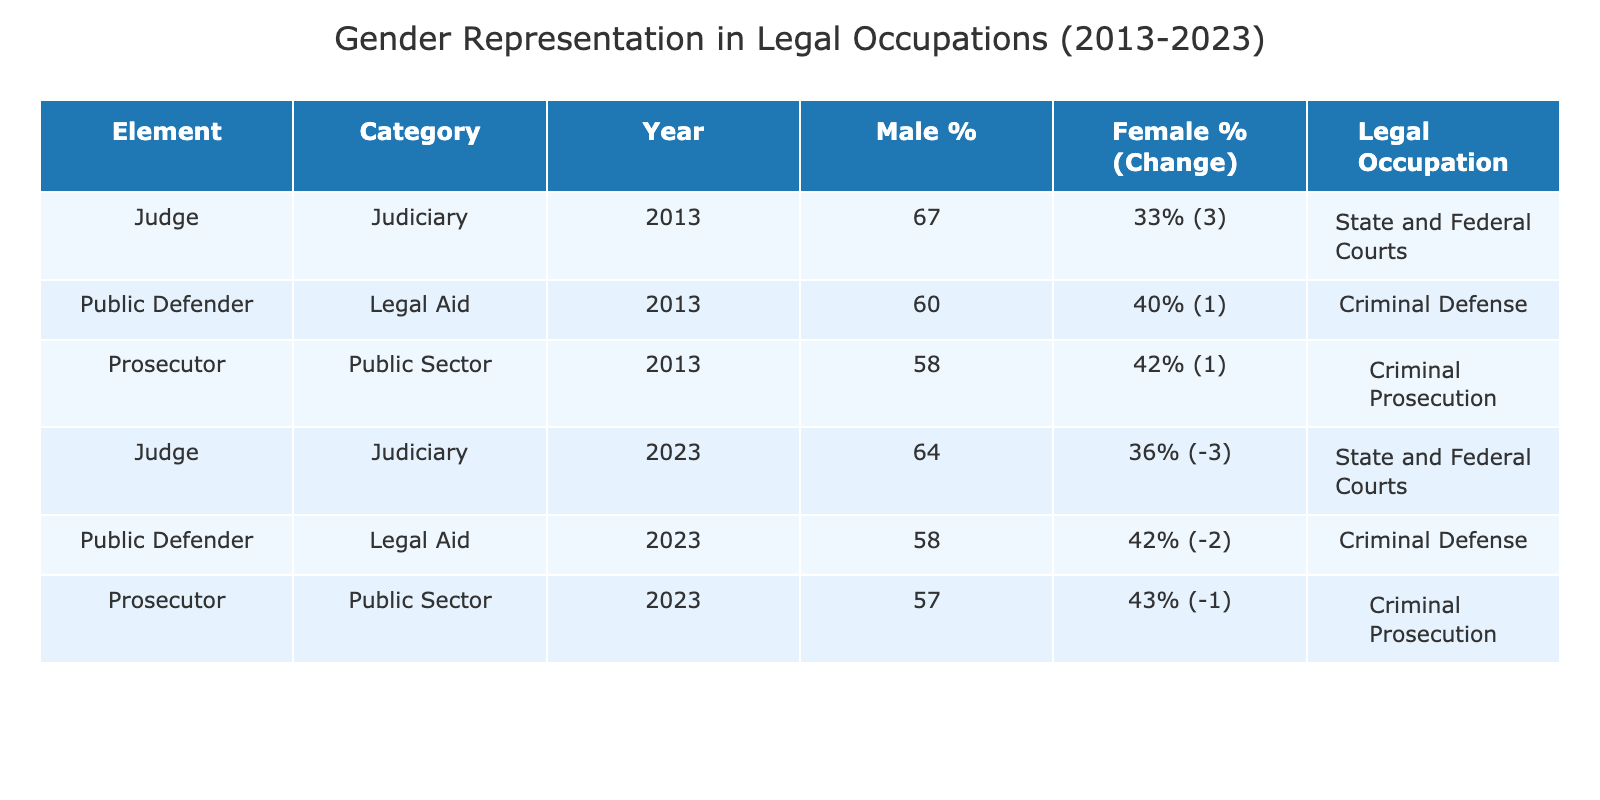What was the female percentage for judges in 2023? The table indicates that for judges in 2023, the female percentage is listed under the female percentage column. From the data, the female percentage is 36%.
Answer: 36% What is the representation change for public defenders from 2013 to 2023? To find the representation change for public defenders, we look at the 'Representation Change' column for 2013 and 2023. In 2013, it is +1, and in 2023, it is -2. The overall change is calculated as -2 - 1 = -3.
Answer: -3 Which legal occupation had the highest male percentage in 2013? In 2013, we compare the male percentages for the legal occupations. Judges had a male percentage of 67%, which is the highest compared to public defenders (60%) and prosecutors (58%).
Answer: Judges Did the female percentage for prosecutors increase over the decade? The female percentages for prosecutors in 2013 and 2023 are 42% and 43%, respectively. Since 43% is greater than 42%, this shows an increase.
Answer: Yes What is the average female percentage across all legal occupations in 2023? The female percentages for 2023 are: 36% (judges), 42% (public defenders), and 43% (prosecutors). We sum these: 36 + 42 + 43 = 121, and then divide by 3 (the number of occupations) to find the average, which is 121/3 = 40.33%.
Answer: 40.33% What is the difference in male percentage for judges from 2013 to 2023? For judges, the male percentage in 2013 is 67%, and in 2023 it is 64%. The difference is calculated as 67 - 64 = 3%.
Answer: 3% Are public defenders equally represented in terms of gender in 2023? In 2023, the female percentage for public defenders is 42% and the male percentage is 58%. Since the percentages are not equal (not 50% each), they are not equally represented.
Answer: No Which legal occupation saw a decline in female representation over the decade? By comparing the representation change for each occupation, we see that judges decreased from 33% to 36%, public defenders went from 40% to 42%, and prosecutors from 42% to 43%. Thus, judges had a decrease in female representation.
Answer: Judges 